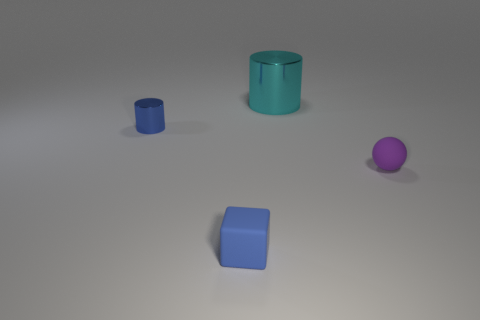There is a metal cylinder right of the tiny rubber thing that is on the left side of the small purple object; how big is it?
Your answer should be compact. Large. There is a blue object that is the same size as the blue cylinder; what material is it?
Your answer should be compact. Rubber. Are there any tiny blue things in front of the tiny shiny object?
Your answer should be very brief. Yes. Are there an equal number of tiny blue objects that are behind the tiny cube and small metallic spheres?
Make the answer very short. No. There is a blue shiny thing that is the same size as the blue block; what shape is it?
Your answer should be compact. Cylinder. What material is the tiny purple sphere?
Offer a very short reply. Rubber. There is a small thing that is both on the right side of the tiny metal cylinder and to the left of the large metal cylinder; what is its color?
Provide a succinct answer. Blue. Is the number of purple balls behind the large object the same as the number of small blue cylinders that are behind the matte block?
Ensure brevity in your answer.  No. The small object that is the same material as the tiny purple ball is what color?
Ensure brevity in your answer.  Blue. There is a tiny cube; does it have the same color as the small thing that is behind the purple rubber object?
Ensure brevity in your answer.  Yes. 